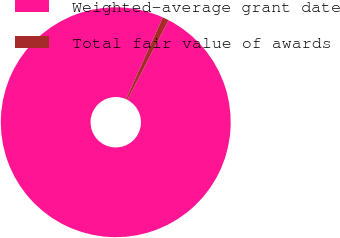Convert chart to OTSL. <chart><loc_0><loc_0><loc_500><loc_500><pie_chart><fcel>Weighted-average grant date<fcel>Total fair value of awards<nl><fcel>99.11%<fcel>0.89%<nl></chart> 